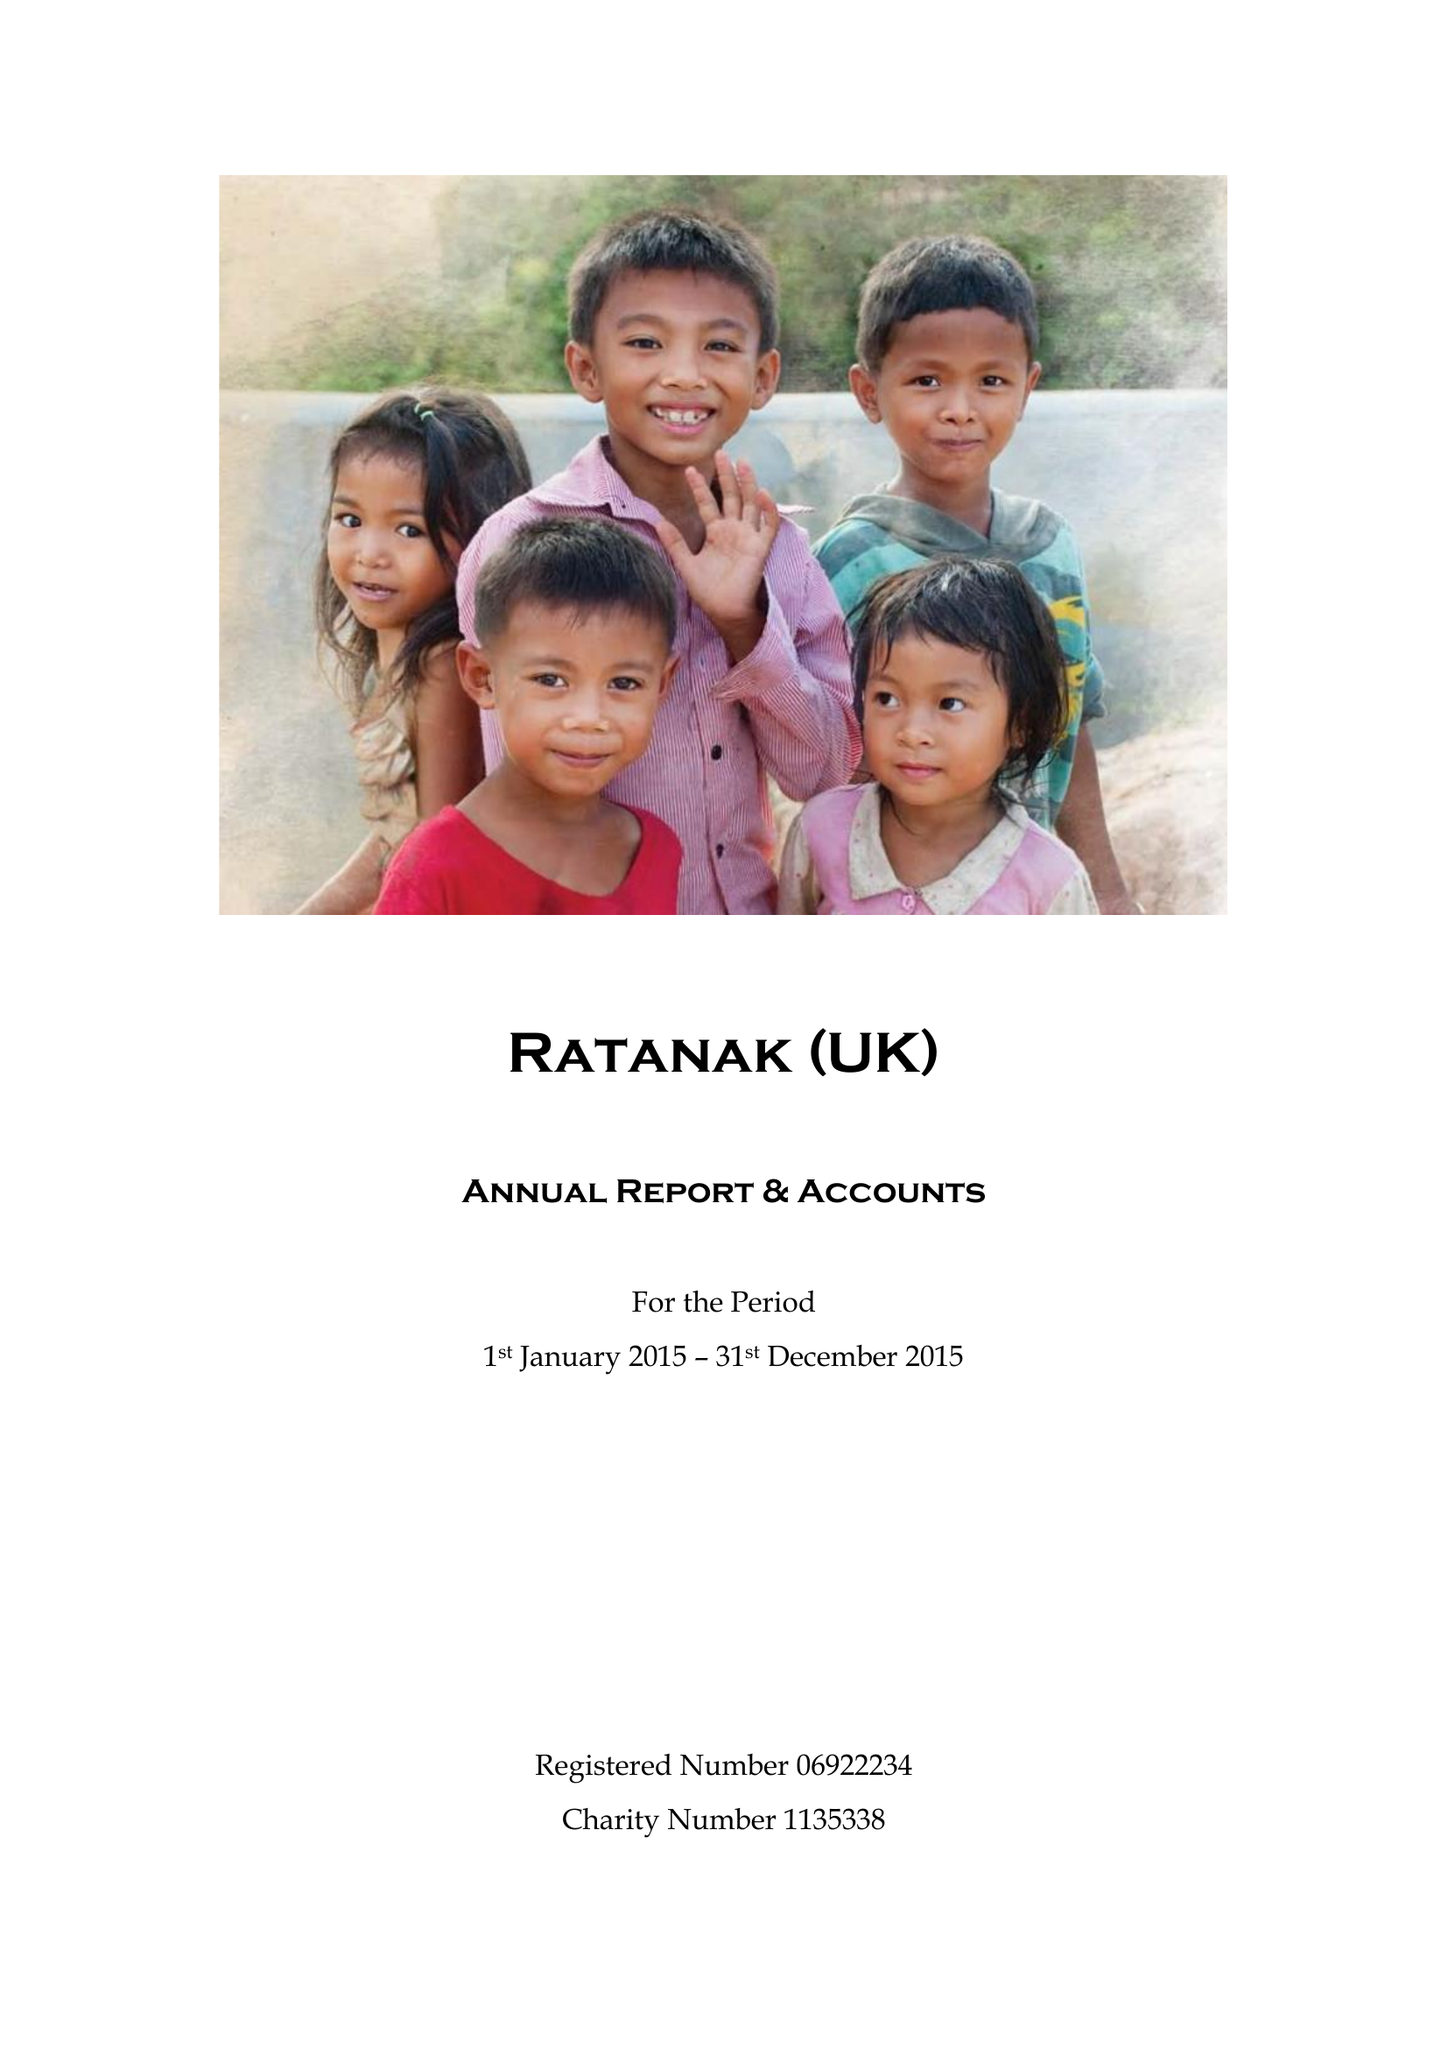What is the value for the charity_number?
Answer the question using a single word or phrase. 1135338 